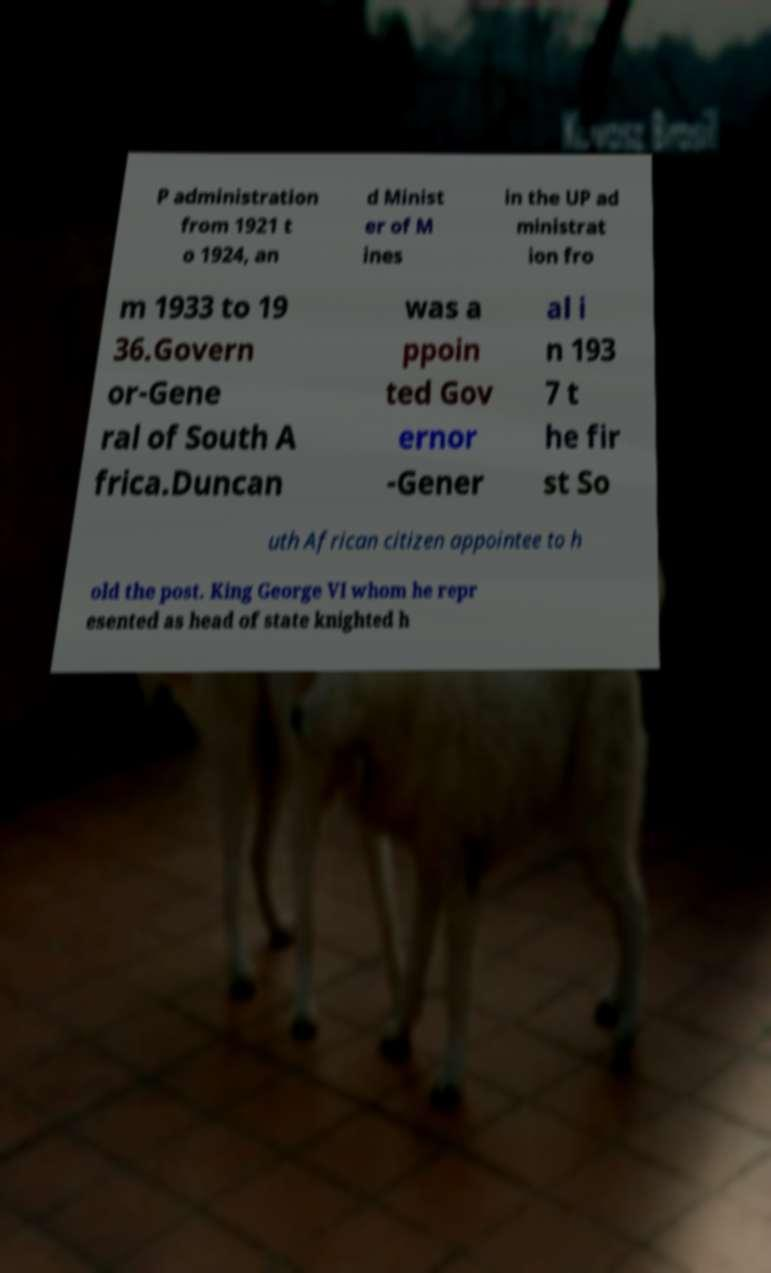I need the written content from this picture converted into text. Can you do that? P administration from 1921 t o 1924, an d Minist er of M ines in the UP ad ministrat ion fro m 1933 to 19 36.Govern or-Gene ral of South A frica.Duncan was a ppoin ted Gov ernor -Gener al i n 193 7 t he fir st So uth African citizen appointee to h old the post. King George VI whom he repr esented as head of state knighted h 